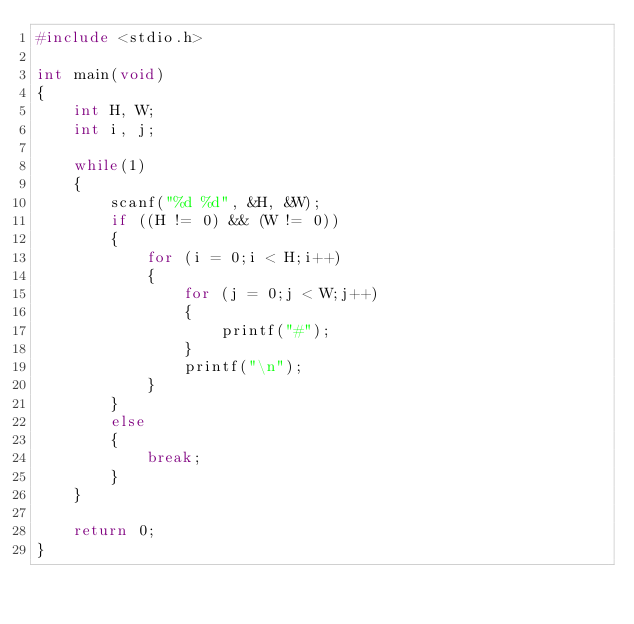<code> <loc_0><loc_0><loc_500><loc_500><_C_>#include <stdio.h>

int main(void)
{
	int H, W;
	int i, j;
	
	while(1)
	{
		scanf("%d %d", &H, &W);
		if ((H != 0) && (W != 0))
		{
			for (i = 0;i < H;i++)
			{
				for (j = 0;j < W;j++)
				{
					printf("#");
				}
				printf("\n");
			}
		}
		else
		{
			break;
		}
	}

	return 0;
}
</code> 